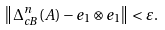Convert formula to latex. <formula><loc_0><loc_0><loc_500><loc_500>\left \| \Delta _ { c B } ^ { n } ( A ) - e _ { 1 } \otimes e _ { 1 } \right \| < \varepsilon .</formula> 